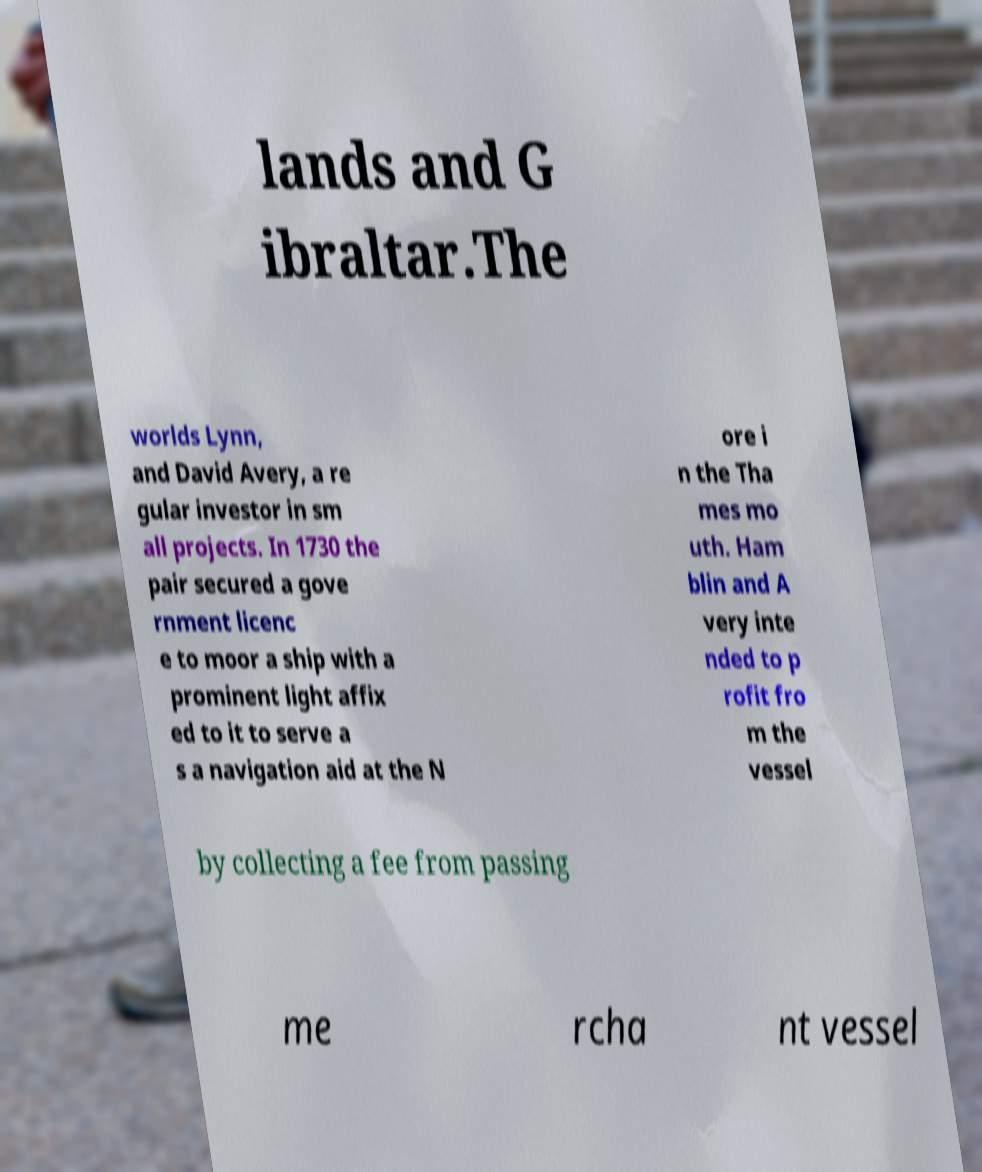Could you assist in decoding the text presented in this image and type it out clearly? lands and G ibraltar.The worlds Lynn, and David Avery, a re gular investor in sm all projects. In 1730 the pair secured a gove rnment licenc e to moor a ship with a prominent light affix ed to it to serve a s a navigation aid at the N ore i n the Tha mes mo uth. Ham blin and A very inte nded to p rofit fro m the vessel by collecting a fee from passing me rcha nt vessel 